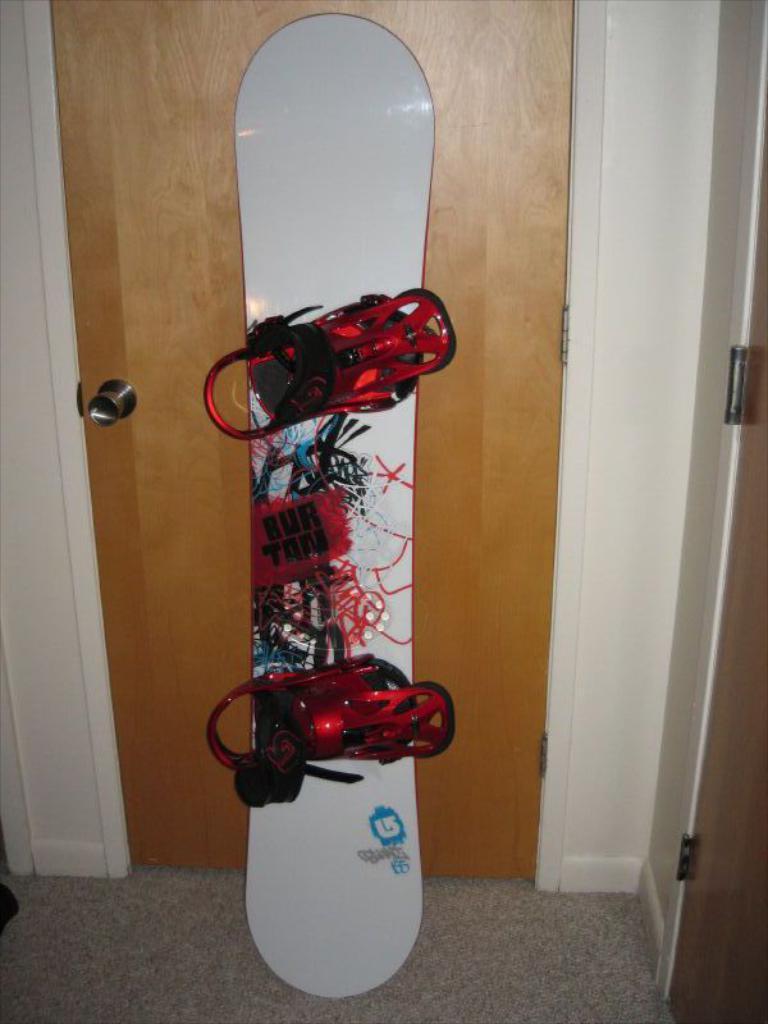How would you summarize this image in a sentence or two? In this image we can see a skateboard on the floor. We can also see a door and a wall. 